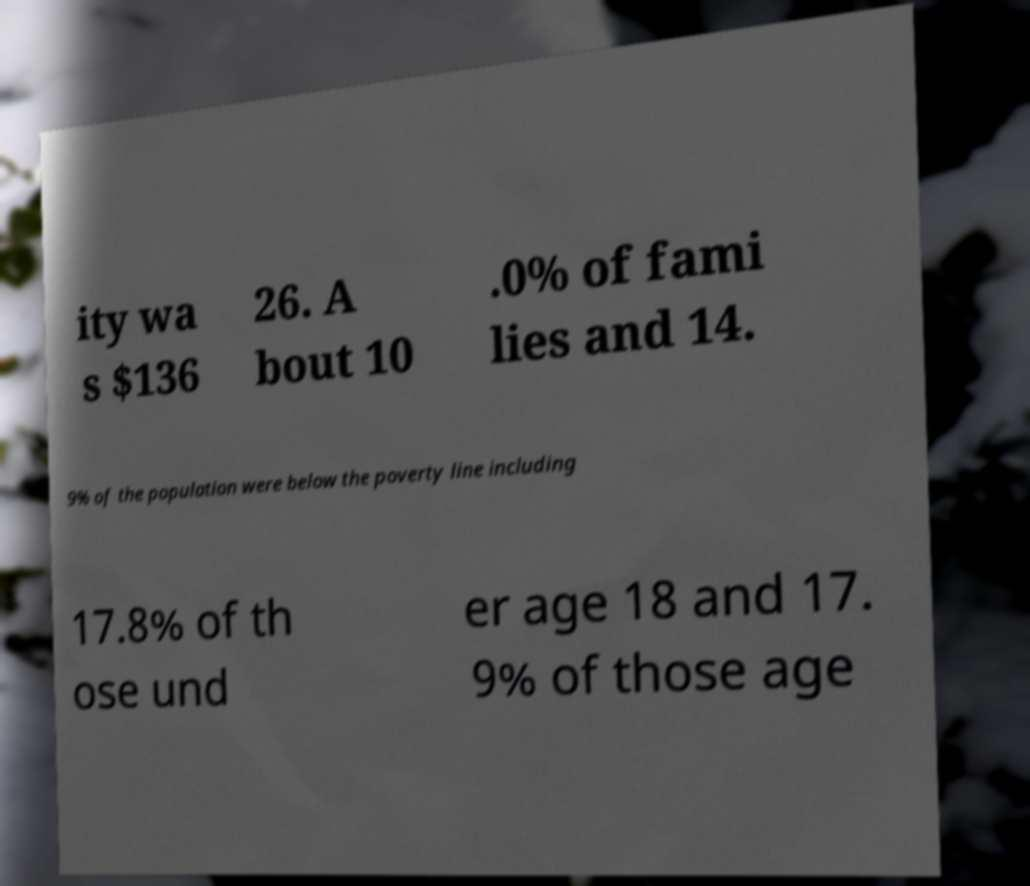What messages or text are displayed in this image? I need them in a readable, typed format. ity wa s $136 26. A bout 10 .0% of fami lies and 14. 9% of the population were below the poverty line including 17.8% of th ose und er age 18 and 17. 9% of those age 